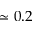<formula> <loc_0><loc_0><loc_500><loc_500>\simeq 0 . 2</formula> 